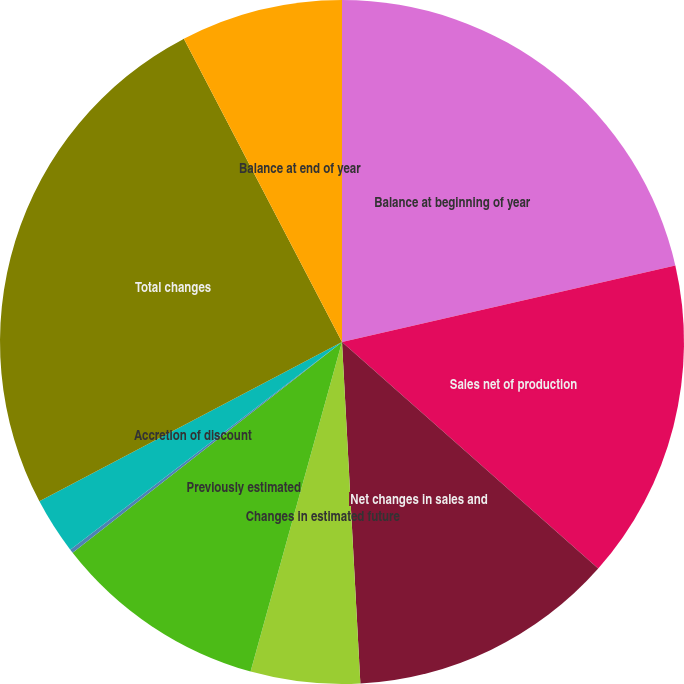<chart> <loc_0><loc_0><loc_500><loc_500><pie_chart><fcel>Balance at beginning of year<fcel>Sales net of production<fcel>Net changes in sales and<fcel>Changes in estimated future<fcel>Previously estimated<fcel>Revisions of quantity<fcel>Accretion of discount<fcel>Total changes<fcel>Balance at end of year<nl><fcel>21.41%<fcel>15.11%<fcel>12.62%<fcel>5.16%<fcel>10.13%<fcel>0.18%<fcel>2.67%<fcel>25.06%<fcel>7.65%<nl></chart> 